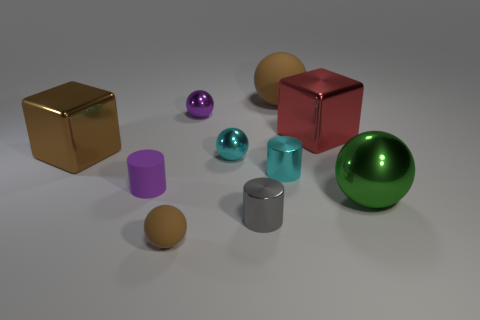Subtract all cyan spheres. How many spheres are left? 4 Subtract all cyan spheres. How many spheres are left? 4 Subtract all red balls. Subtract all purple cubes. How many balls are left? 5 Subtract all cylinders. How many objects are left? 7 Add 6 big yellow objects. How many big yellow objects exist? 6 Subtract 1 brown blocks. How many objects are left? 9 Subtract all large blue cylinders. Subtract all small cyan cylinders. How many objects are left? 9 Add 2 tiny gray metal cylinders. How many tiny gray metal cylinders are left? 3 